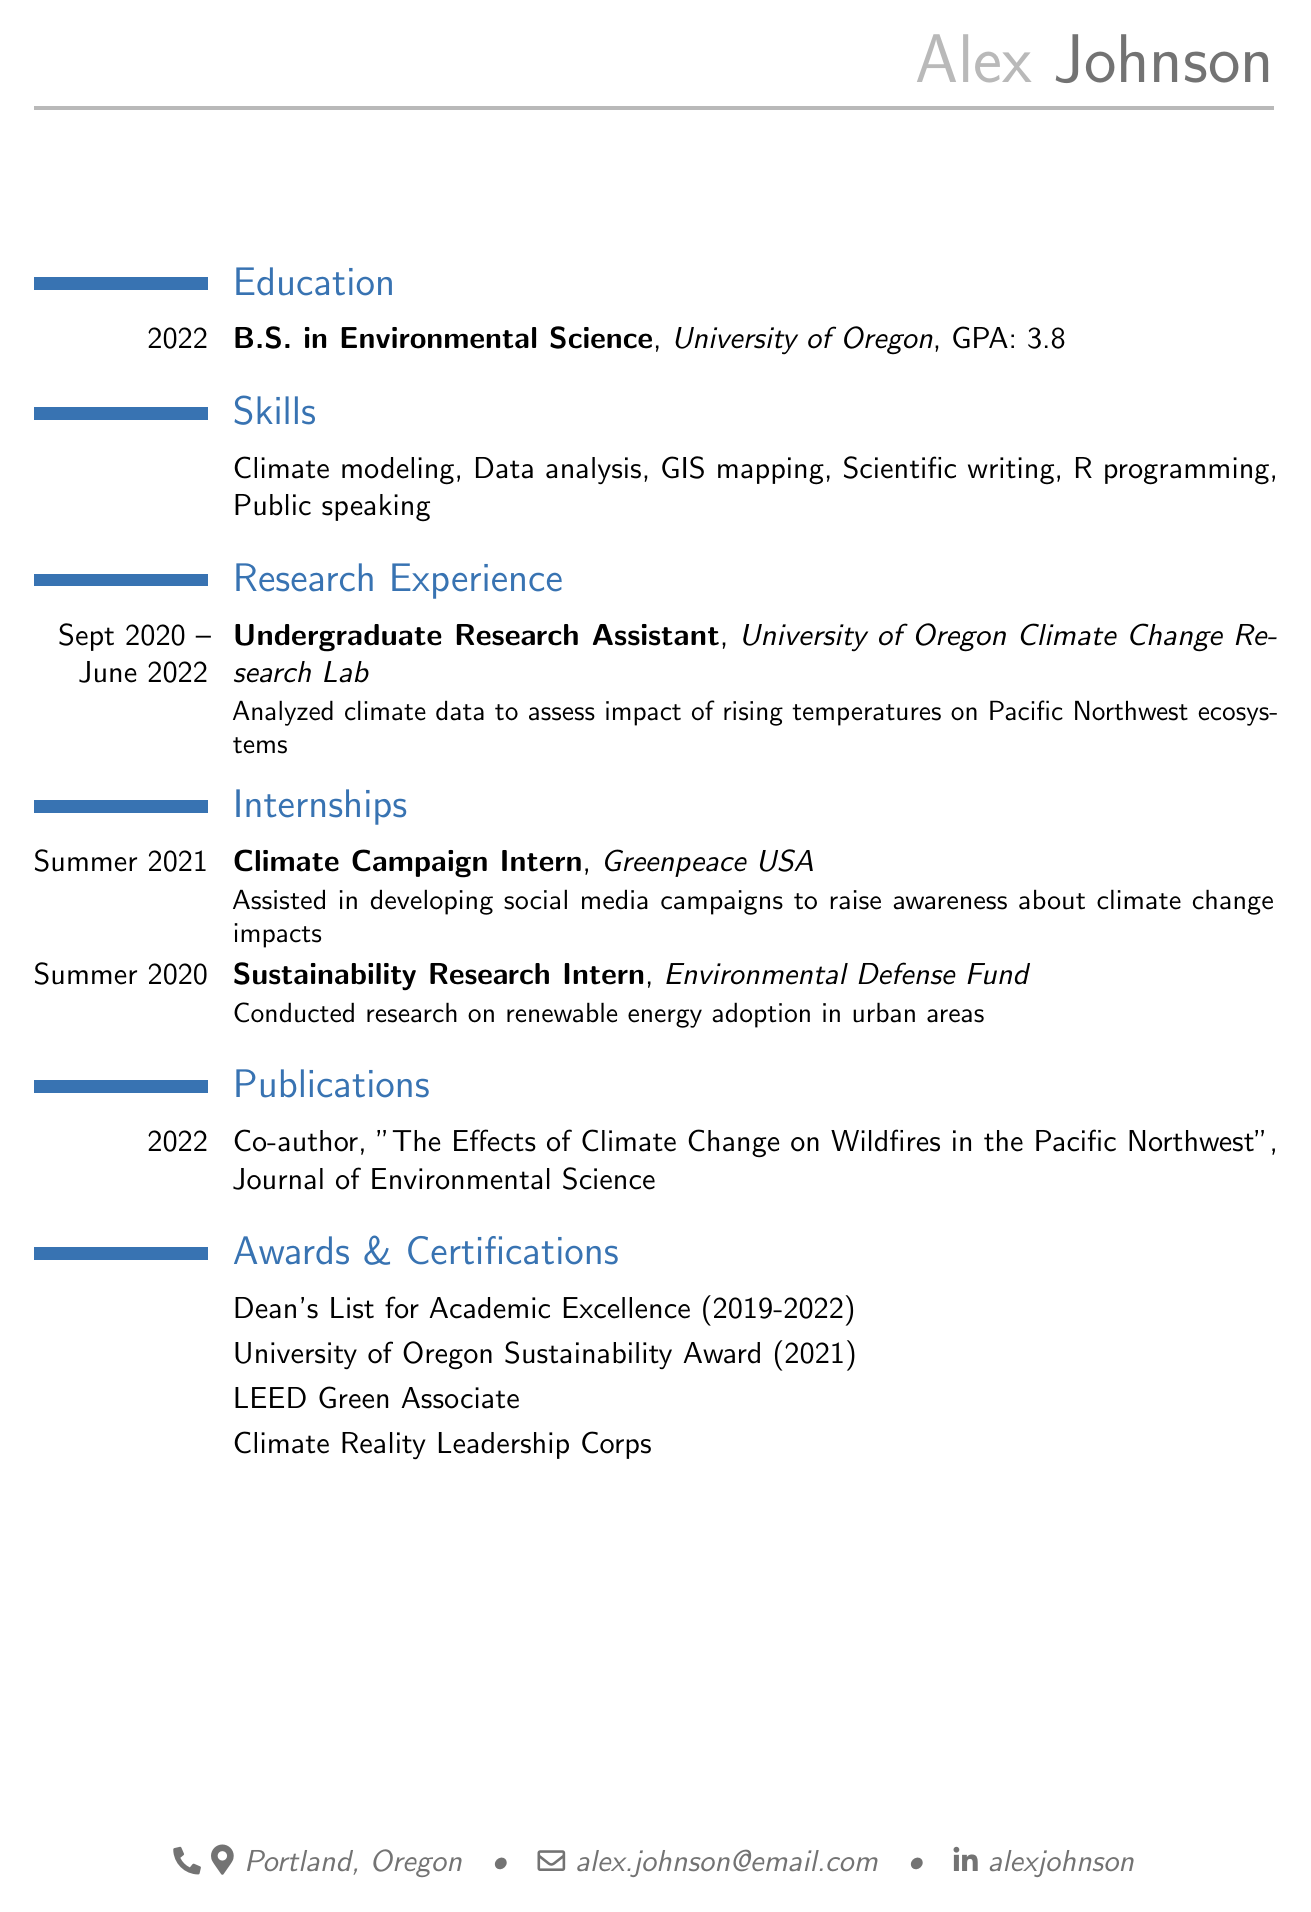What degree did Alex Johnson earn? Alex Johnson earned a B.S. in Environmental Science from the University of Oregon.
Answer: B.S. in Environmental Science What was Alex's GPA? The GPA listed in the document shows Alex's academic achievement over their education period.
Answer: 3.8 Which organization did Alex intern at during Summer 2021? The document specifies that Alex worked at Greenpeace USA as a Climate Campaign Intern during Summer 2021.
Answer: Greenpeace USA What is one of Alex's skills listed in the document? The document lists a variety of skills, which indicate Alex's competencies in environmental science.
Answer: Climate modeling In which journal was Alex's publication featured? The publication section reveals the journal where Alex co-authored an article.
Answer: Journal of Environmental Science How many years did Alex work as an Undergraduate Research Assistant? The duration of the research experience is specified in the document, showing how long Alex engaged in the position.
Answer: 2 years What award did Alex receive from the University of Oregon? The awards section outlines recognitions that highlight Alex's achievements during their studies.
Answer: University of Oregon Sustainability Award What certification does Alex hold related to leadership in climate action? The certifications section indicates Alex's involvement in climate leadership programs.
Answer: Climate Reality Leadership Corps 